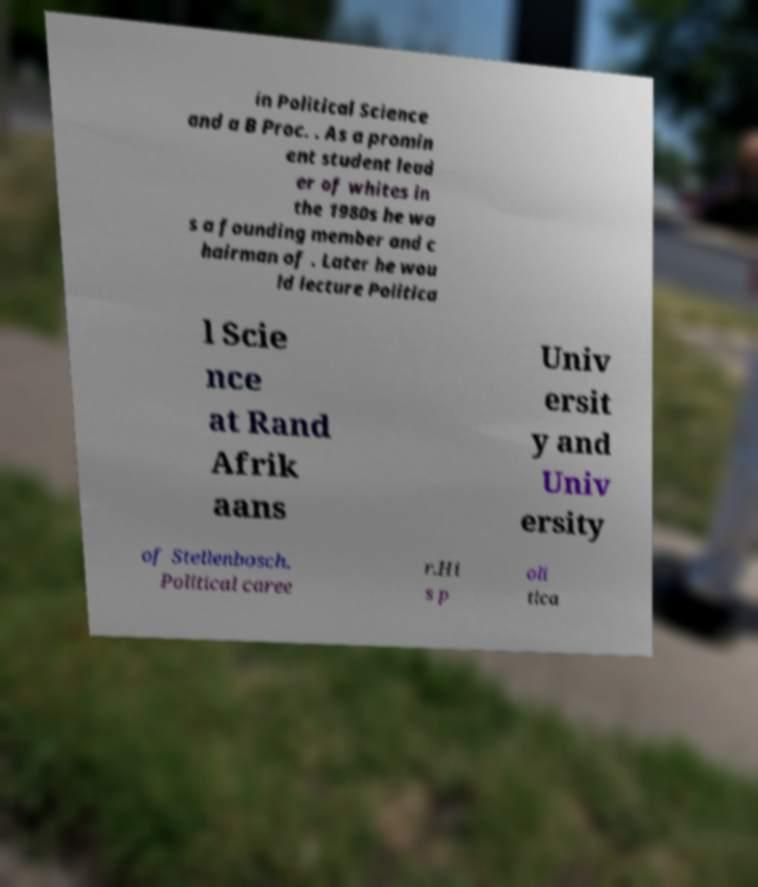Could you assist in decoding the text presented in this image and type it out clearly? in Political Science and a B Proc. . As a promin ent student lead er of whites in the 1980s he wa s a founding member and c hairman of . Later he wou ld lecture Politica l Scie nce at Rand Afrik aans Univ ersit y and Univ ersity of Stellenbosch. Political caree r.Hi s p oli tica 